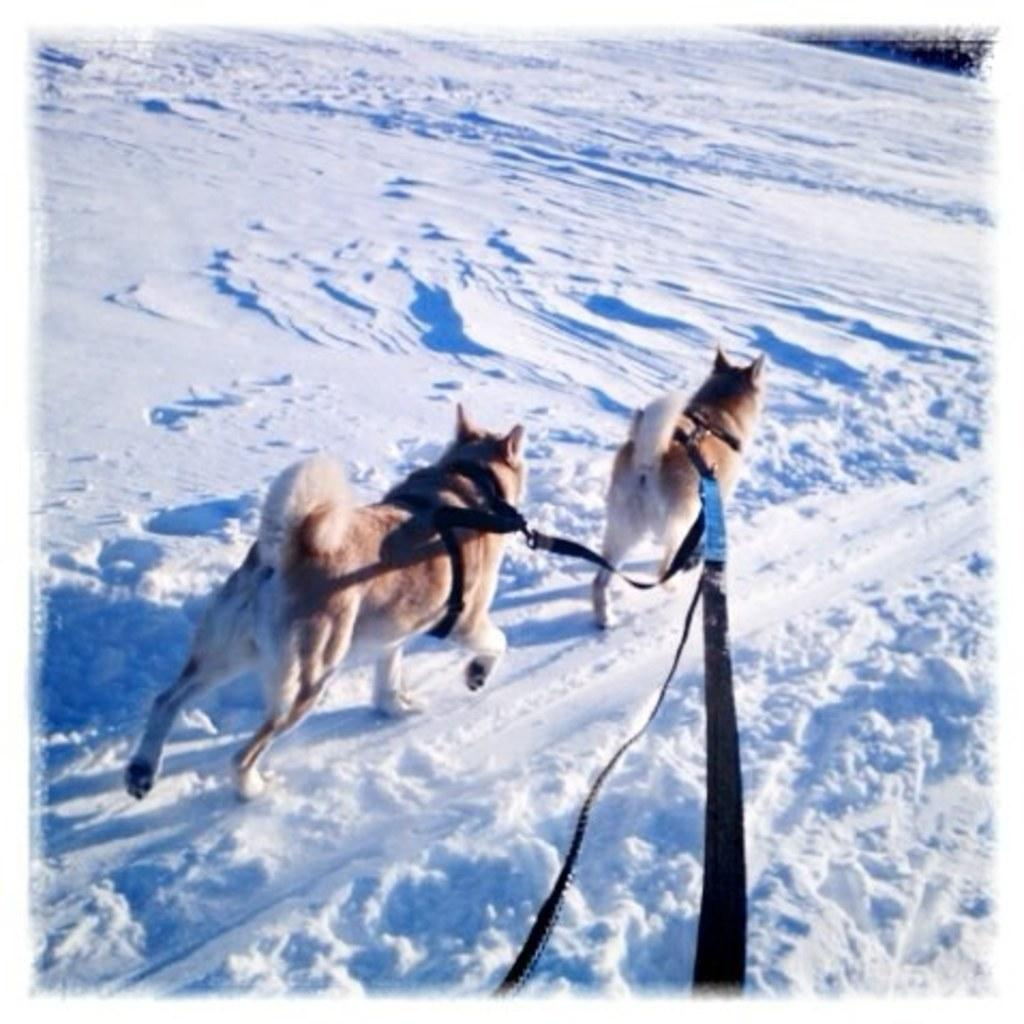How many dogs are present in the image? There are two dogs in the image. What is the condition of the land in the image? There is snow on the land in the image. What can be seen around the dogs' necks? The dogs have collars around their necks. What type of salt can be seen on the dogs' fur in the image? There is no salt visible on the dogs' fur in the image. What kind of trouble are the dogs causing in the image? The image does not depict any trouble caused by the dogs. 